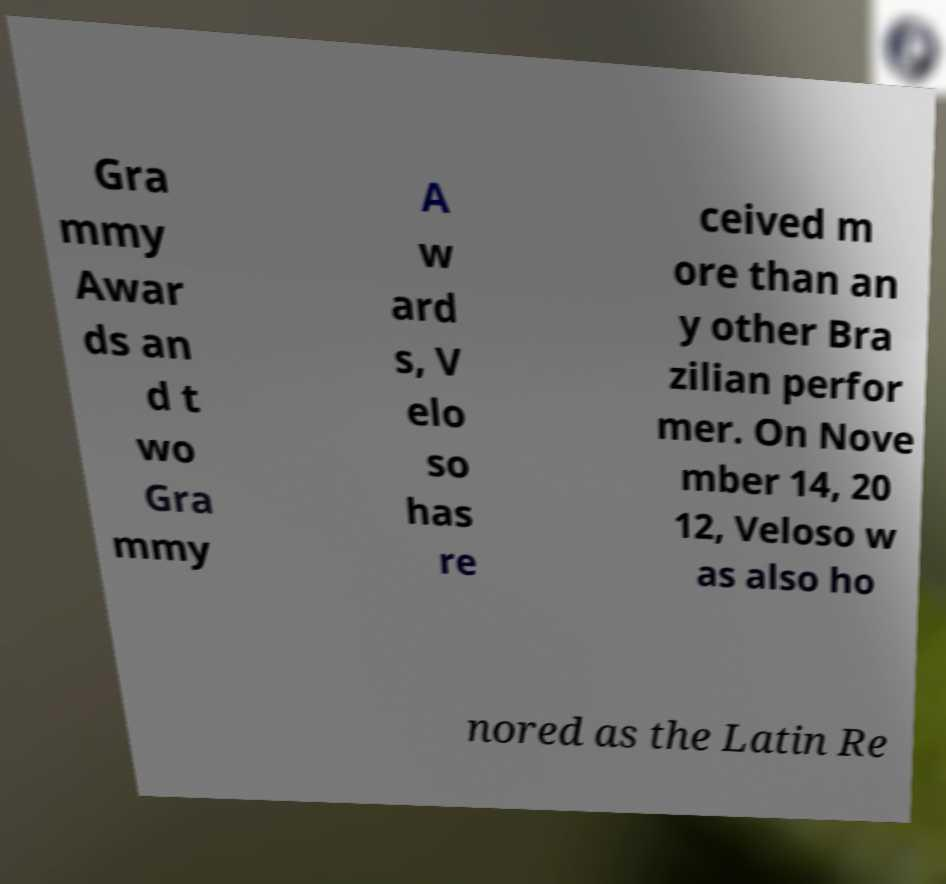I need the written content from this picture converted into text. Can you do that? Gra mmy Awar ds an d t wo Gra mmy A w ard s, V elo so has re ceived m ore than an y other Bra zilian perfor mer. On Nove mber 14, 20 12, Veloso w as also ho nored as the Latin Re 